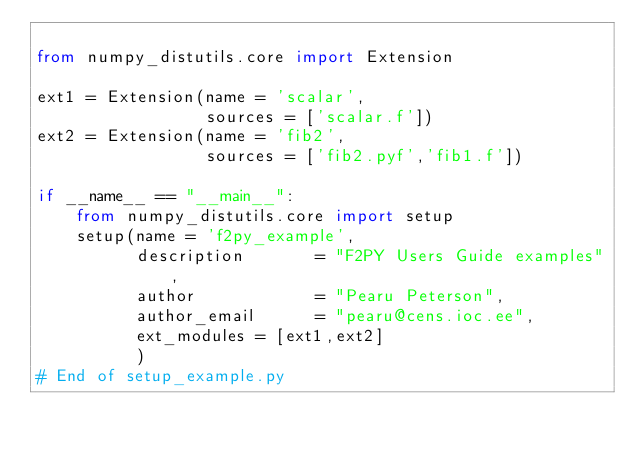<code> <loc_0><loc_0><loc_500><loc_500><_Python_>
from numpy_distutils.core import Extension

ext1 = Extension(name = 'scalar',
                 sources = ['scalar.f'])
ext2 = Extension(name = 'fib2',
                 sources = ['fib2.pyf','fib1.f'])

if __name__ == "__main__":
    from numpy_distutils.core import setup
    setup(name = 'f2py_example',
          description       = "F2PY Users Guide examples",
          author            = "Pearu Peterson",
          author_email      = "pearu@cens.ioc.ee",
          ext_modules = [ext1,ext2]
          )
# End of setup_example.py
</code> 